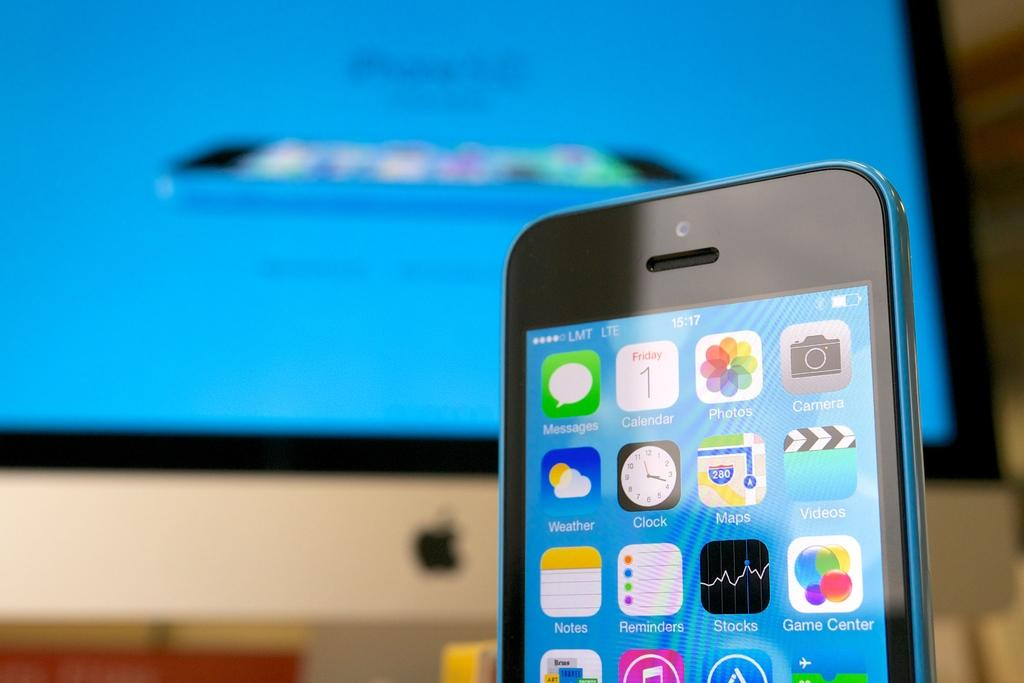What is the main object in the foreground of the image? There is a mobile in the foreground of the image. What can be seen in the background of the image? There is a monitor in the background of the image. How many notebooks can be seen on the mobile in the image? There are no notebooks present in the image; it features a mobile and a monitor. What is the value of the dime on the monitor in the image? There is no dime present on the monitor in the image. 